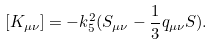Convert formula to latex. <formula><loc_0><loc_0><loc_500><loc_500>[ K _ { \mu \nu } ] = - k ^ { 2 } _ { 5 } ( S _ { \mu \nu } - \frac { 1 } { 3 } q _ { \mu \nu } S ) .</formula> 